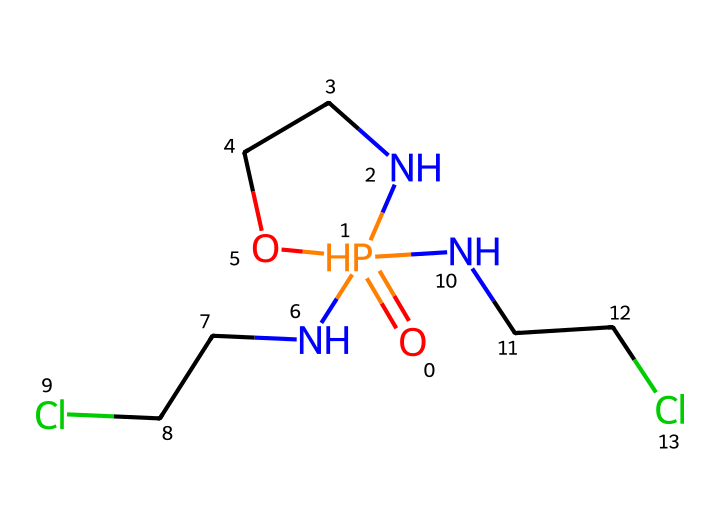How many amine groups are present in this compound? In the SMILES representation, there are three NCC groups, where "N" indicates nitrogen, which is characteristic of amine groups. Each NCC corresponds to one amine group. Therefore, counting the number of amine groups, we find three.
Answer: three What is the functional group present in this chemical? The presence of the "O=P" part indicates that this compound has a phosphate functional group. Phosphoric compounds are characterized by this feature, and it is evident in the SMILES as well.
Answer: phosphate How many carbon atoms are in cyclophosphamide? In the SMILES representation, we count the carbon atoms from the NCC parts, noting each NCC contains two carbons, and there are three NCC segments, resulting in six carbon atoms total.
Answer: six Does this compound contain any halogen atoms? The presence of "Cl" in the SMILES indicates that there are chlorinated atoms in the compound. A direct observation shows two occurrences of "Cl," confirming halogen atoms are indeed present.
Answer: yes What type of ring structure is formed in this compound? The "O=P" structure suggests that the nitrogen atoms are part of a cyclic formation due to the "1" notation, which indicates a ring closure. The cycloalkane structure is evident in the cyclic connections with the nitrogen atoms taking part in forming the cycle.
Answer: cycloalkane Is cyclophosphamide considered to be reactive or stable? Cyclophosphamide is known to be an alkylating agent, which indicates that it has reactive properties due to the ability to modify other molecules, particularly in the context of cancer therapy.
Answer: reactive 